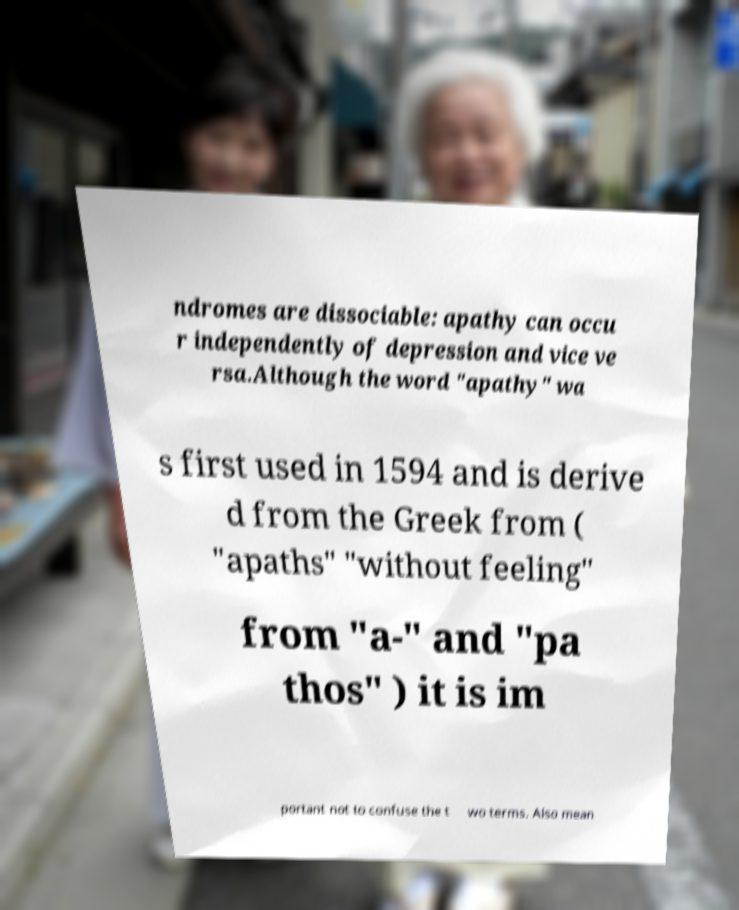For documentation purposes, I need the text within this image transcribed. Could you provide that? ndromes are dissociable: apathy can occu r independently of depression and vice ve rsa.Although the word "apathy" wa s first used in 1594 and is derive d from the Greek from ( "apaths" "without feeling" from "a-" and "pa thos" ) it is im portant not to confuse the t wo terms. Also mean 